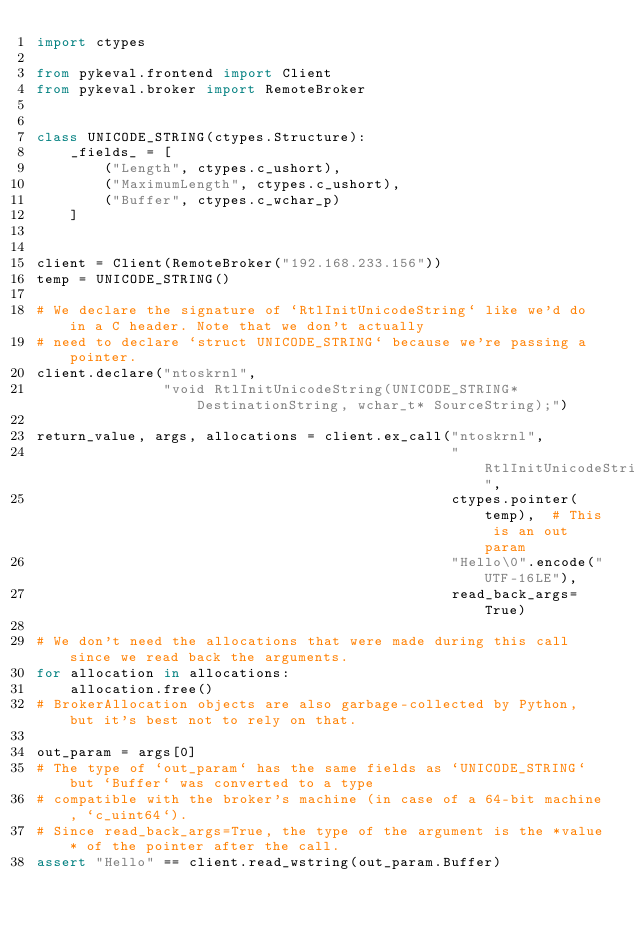<code> <loc_0><loc_0><loc_500><loc_500><_Python_>import ctypes

from pykeval.frontend import Client
from pykeval.broker import RemoteBroker


class UNICODE_STRING(ctypes.Structure):
    _fields_ = [
        ("Length", ctypes.c_ushort),
        ("MaximumLength", ctypes.c_ushort),
        ("Buffer", ctypes.c_wchar_p)
    ]


client = Client(RemoteBroker("192.168.233.156"))
temp = UNICODE_STRING()

# We declare the signature of `RtlInitUnicodeString` like we'd do in a C header. Note that we don't actually
# need to declare `struct UNICODE_STRING` because we're passing a pointer.
client.declare("ntoskrnl",
               "void RtlInitUnicodeString(UNICODE_STRING* DestinationString, wchar_t* SourceString);")

return_value, args, allocations = client.ex_call("ntoskrnl",
                                                 "RtlInitUnicodeString",
                                                 ctypes.pointer(temp),  # This is an out param
                                                 "Hello\0".encode("UTF-16LE"),
                                                 read_back_args=True)

# We don't need the allocations that were made during this call since we read back the arguments.
for allocation in allocations:
    allocation.free()
# BrokerAllocation objects are also garbage-collected by Python, but it's best not to rely on that.

out_param = args[0]
# The type of `out_param` has the same fields as `UNICODE_STRING` but `Buffer` was converted to a type
# compatible with the broker's machine (in case of a 64-bit machine, `c_uint64`).
# Since read_back_args=True, the type of the argument is the *value* of the pointer after the call.
assert "Hello" == client.read_wstring(out_param.Buffer)
</code> 